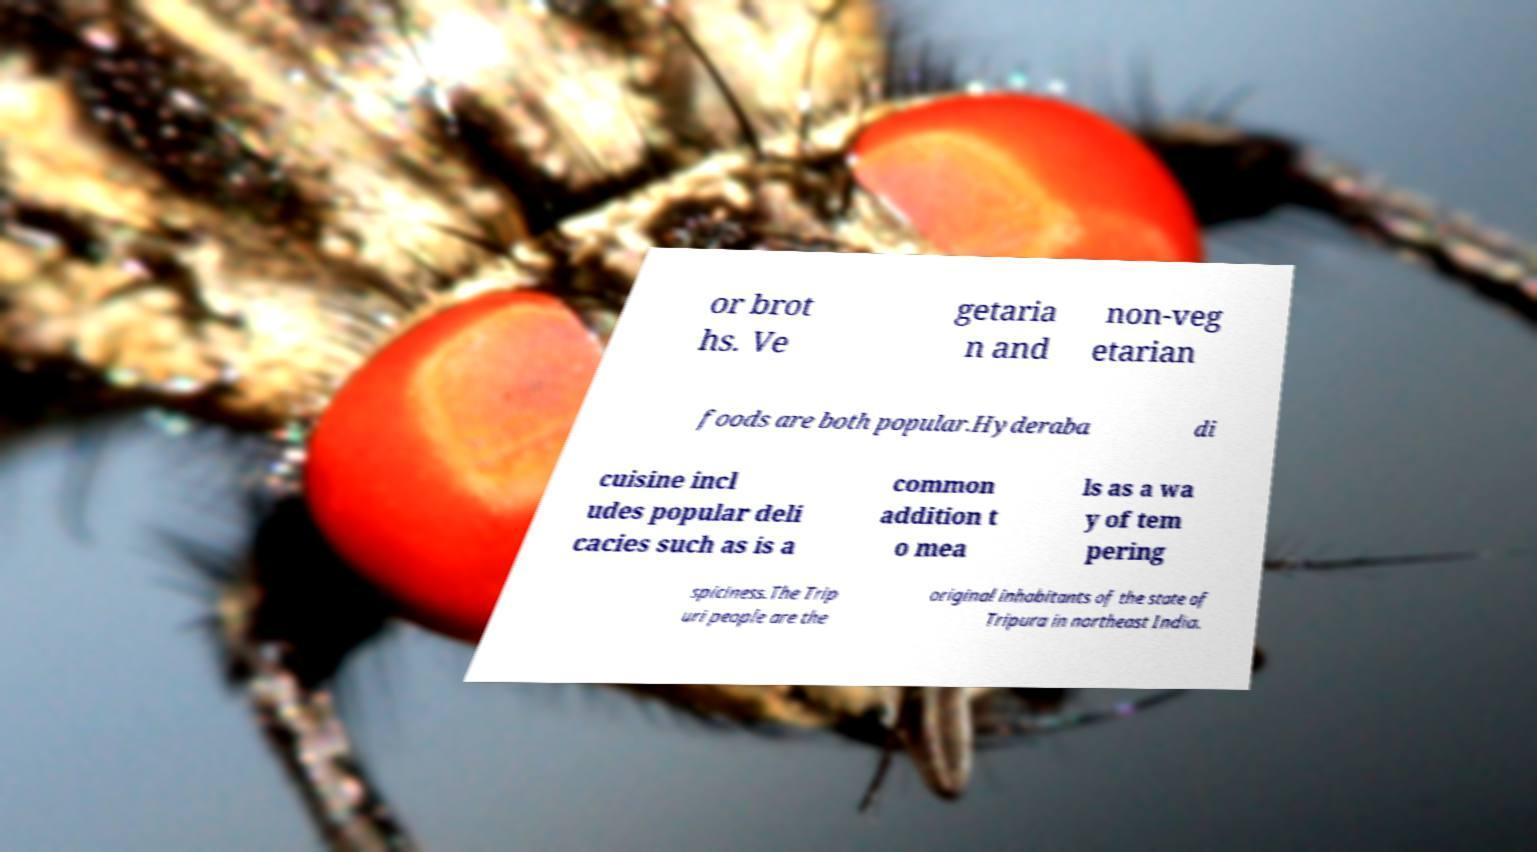I need the written content from this picture converted into text. Can you do that? or brot hs. Ve getaria n and non-veg etarian foods are both popular.Hyderaba di cuisine incl udes popular deli cacies such as is a common addition t o mea ls as a wa y of tem pering spiciness.The Trip uri people are the original inhabitants of the state of Tripura in northeast India. 